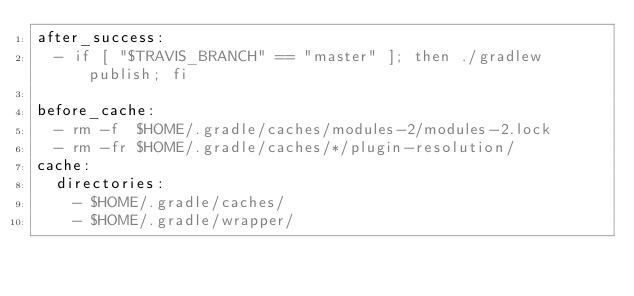<code> <loc_0><loc_0><loc_500><loc_500><_YAML_>after_success:
  - if [ "$TRAVIS_BRANCH" == "master" ]; then ./gradlew publish; fi

before_cache:
  - rm -f  $HOME/.gradle/caches/modules-2/modules-2.lock
  - rm -fr $HOME/.gradle/caches/*/plugin-resolution/
cache:
  directories:
    - $HOME/.gradle/caches/
    - $HOME/.gradle/wrapper/
</code> 